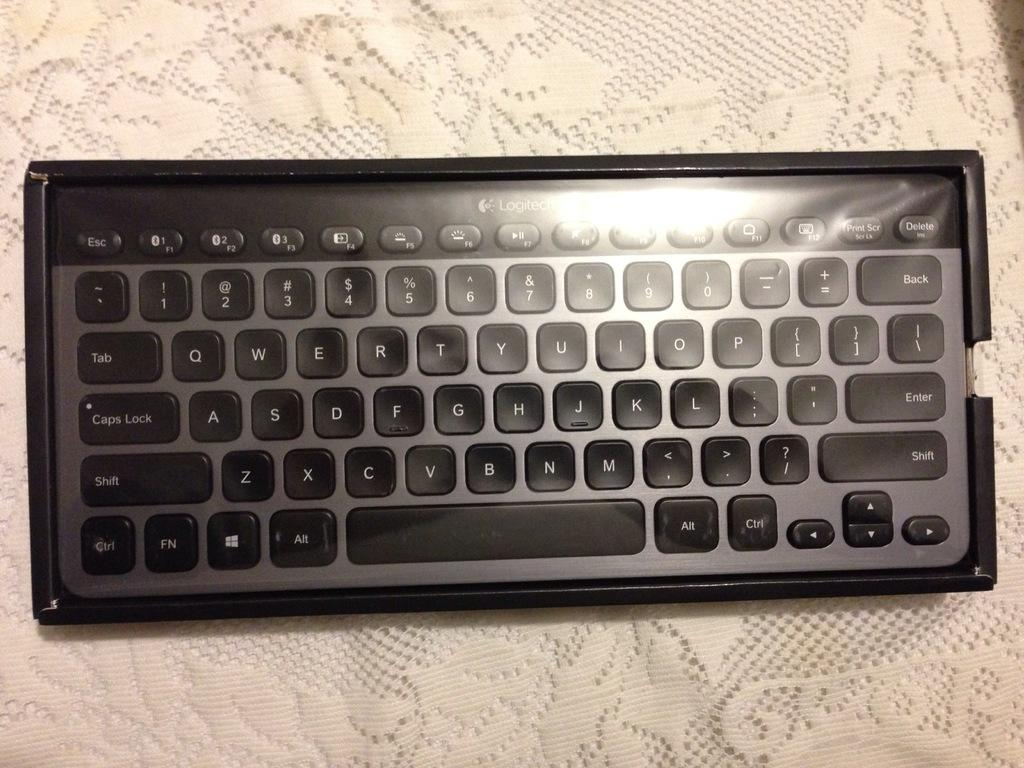<image>
Summarize the visual content of the image. Keyboard in a box that has the Tab key above the Caps lock key. 